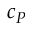<formula> <loc_0><loc_0><loc_500><loc_500>c _ { P }</formula> 